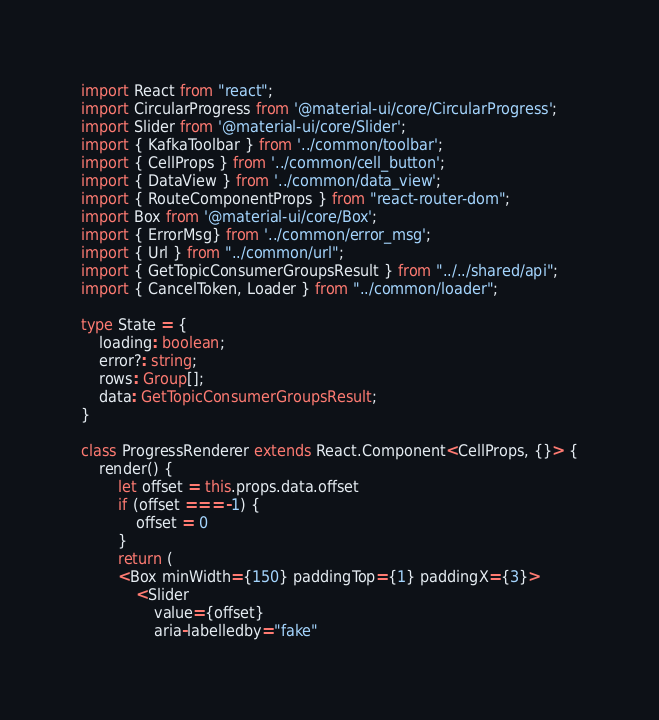Convert code to text. <code><loc_0><loc_0><loc_500><loc_500><_TypeScript_>import React from "react";
import CircularProgress from '@material-ui/core/CircularProgress';
import Slider from '@material-ui/core/Slider';
import { KafkaToolbar } from '../common/toolbar';
import { CellProps } from '../common/cell_button';
import { DataView } from '../common/data_view';
import { RouteComponentProps } from "react-router-dom";
import Box from '@material-ui/core/Box';
import { ErrorMsg} from '../common/error_msg';
import { Url } from "../common/url";
import { GetTopicConsumerGroupsResult } from "../../shared/api";
import { CancelToken, Loader } from "../common/loader";

type State = {
    loading: boolean;
    error?: string;
    rows: Group[];
    data: GetTopicConsumerGroupsResult;
}

class ProgressRenderer extends React.Component<CellProps, {}> {
    render() {
        let offset = this.props.data.offset
        if (offset === -1) {
            offset = 0
        }
        return (
        <Box minWidth={150} paddingTop={1} paddingX={3}>
            <Slider
                value={offset}
                aria-labelledby="fake"</code> 